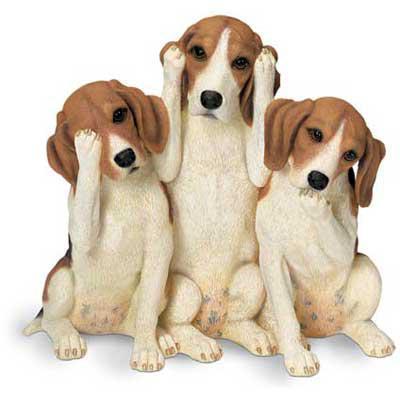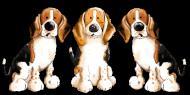The first image is the image on the left, the second image is the image on the right. For the images displayed, is the sentence "There are three dogs in each of the images." factually correct? Answer yes or no. Yes. 